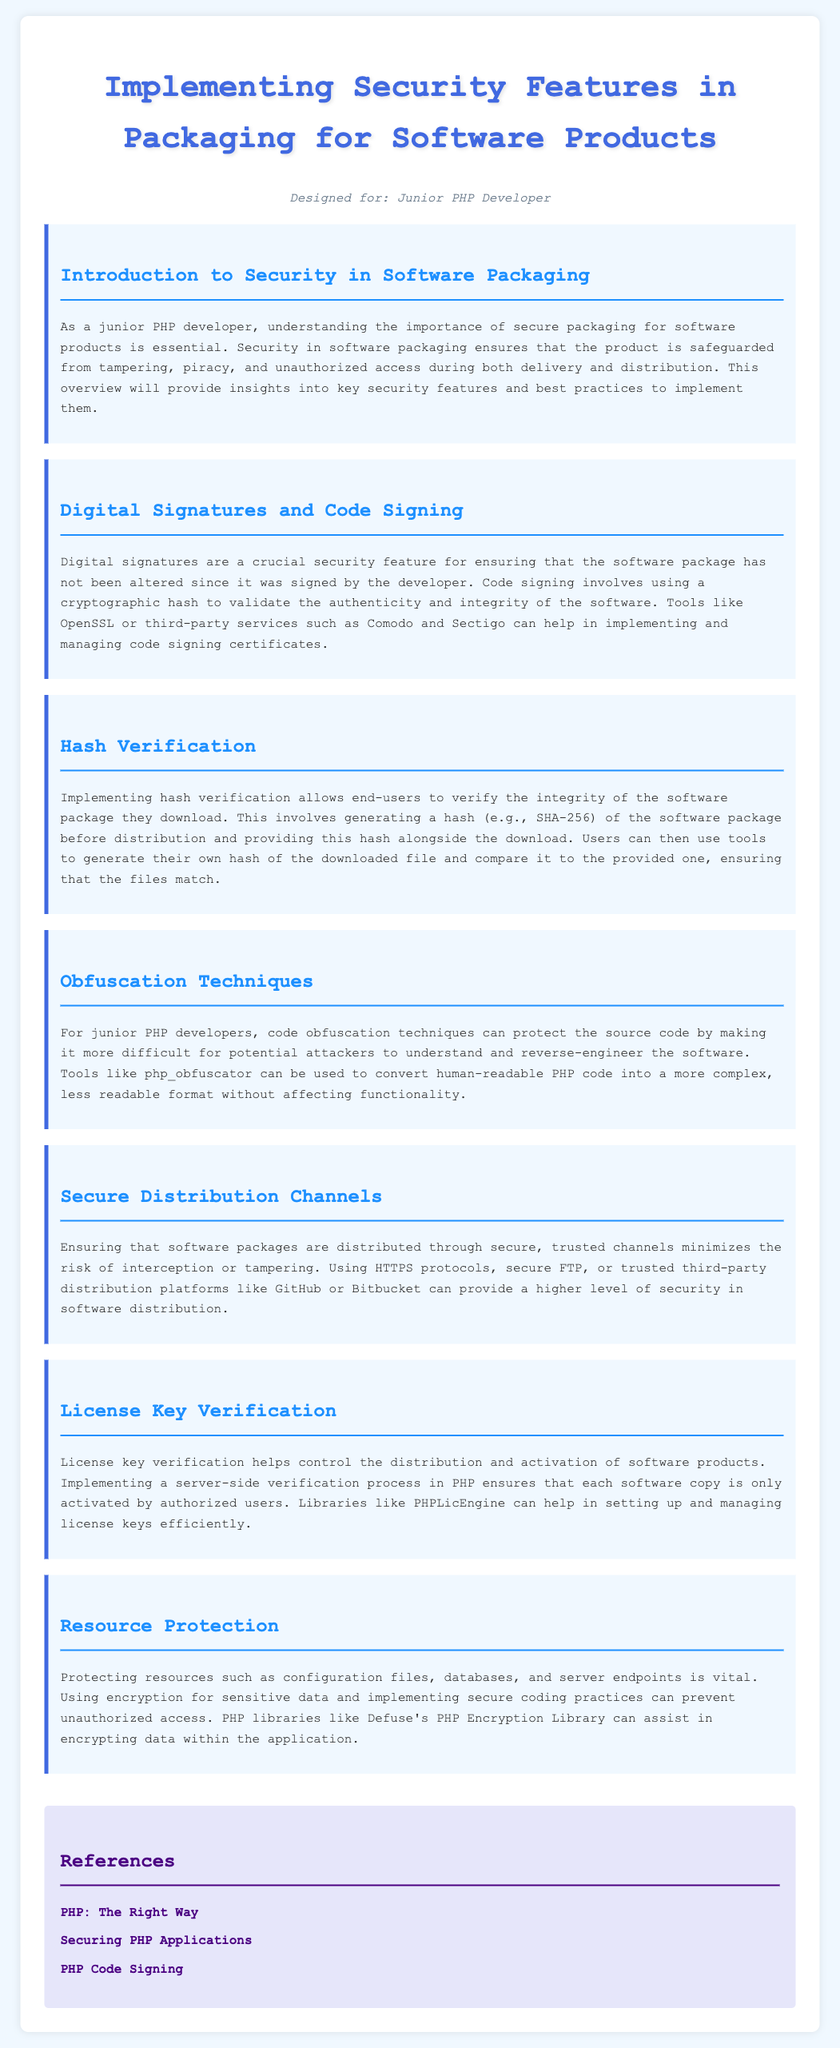What is the title of the document? The title is found in the header section of the document, designed to provide an overview of the content.
Answer: Implementing Security Features in Packaging for Software Products Who is the document designed for? The intended audience is specified at the beginning of the document, noting the target reader.
Answer: Junior PHP Developer What is one tool for digital signatures mentioned in the document? The document lists tools that can help with code signing, specifically mentioning one example.
Answer: OpenSSL What technique helps protect source code from reverse-engineering? The document describes methods for protecting code, highlighting a specific approach suitable for PHP development.
Answer: Obfuscation techniques Which cryptographic hash is recommended for hash verification? The document specifies a hash method recommended for verifying the integrity of the software package.
Answer: SHA-256 What is a feature that controls the activation of software products? The document mentions a specific method used to manage software activation to prevent unauthorized access.
Answer: License key verification Which library can assist in encrypting data? The document provides an example of a PHP library that helps with data protection through encryption.
Answer: Defuse's PHP Encryption Library What is essential for secure software distribution? The document emphasizes practices that improve distribution security, pointing to a specific requirement.
Answer: Secure channels What does code signing ensure? The document outlines the purpose of code signing in relation to software integrity.
Answer: Authenticity and integrity 